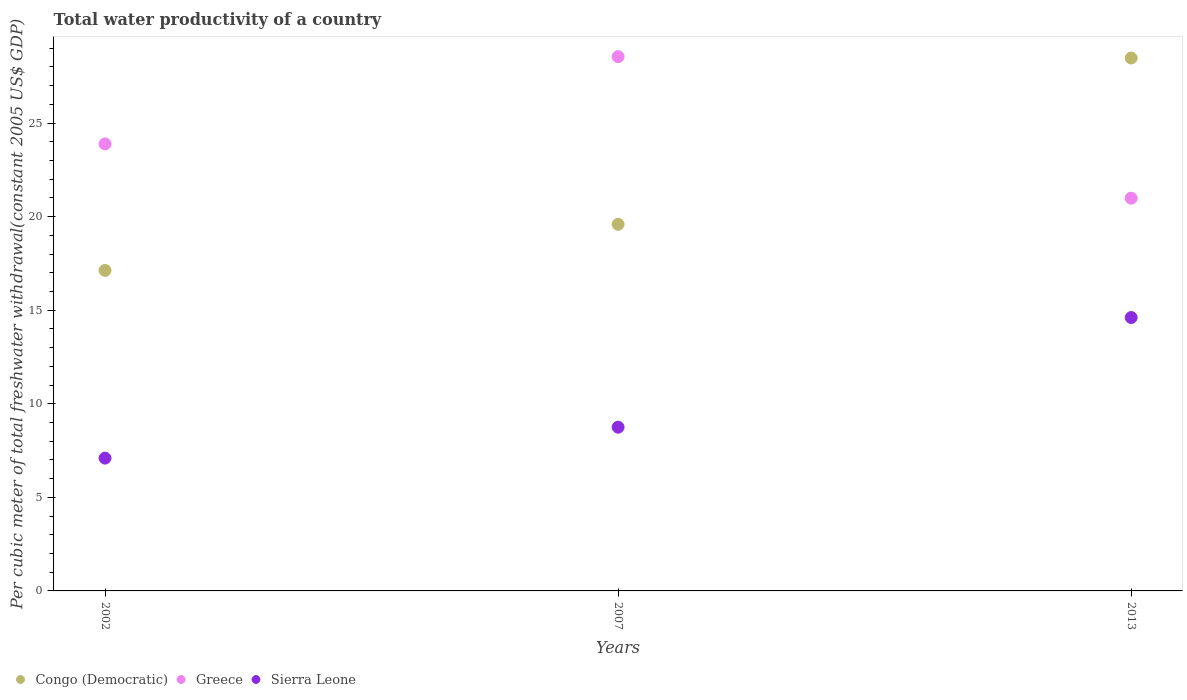Is the number of dotlines equal to the number of legend labels?
Offer a terse response. Yes. What is the total water productivity in Sierra Leone in 2013?
Give a very brief answer. 14.61. Across all years, what is the maximum total water productivity in Sierra Leone?
Offer a very short reply. 14.61. Across all years, what is the minimum total water productivity in Sierra Leone?
Offer a terse response. 7.1. In which year was the total water productivity in Sierra Leone maximum?
Provide a short and direct response. 2013. What is the total total water productivity in Congo (Democratic) in the graph?
Your answer should be compact. 65.19. What is the difference between the total water productivity in Congo (Democratic) in 2002 and that in 2007?
Your answer should be very brief. -2.46. What is the difference between the total water productivity in Sierra Leone in 2002 and the total water productivity in Greece in 2013?
Your response must be concise. -13.89. What is the average total water productivity in Greece per year?
Keep it short and to the point. 24.47. In the year 2007, what is the difference between the total water productivity in Greece and total water productivity in Sierra Leone?
Keep it short and to the point. 19.8. What is the ratio of the total water productivity in Greece in 2002 to that in 2007?
Your response must be concise. 0.84. What is the difference between the highest and the second highest total water productivity in Sierra Leone?
Give a very brief answer. 5.86. What is the difference between the highest and the lowest total water productivity in Greece?
Ensure brevity in your answer.  7.56. Is the sum of the total water productivity in Sierra Leone in 2002 and 2013 greater than the maximum total water productivity in Greece across all years?
Your answer should be compact. No. Is the total water productivity in Congo (Democratic) strictly greater than the total water productivity in Greece over the years?
Make the answer very short. No. Is the total water productivity in Sierra Leone strictly less than the total water productivity in Congo (Democratic) over the years?
Offer a very short reply. Yes. What is the difference between two consecutive major ticks on the Y-axis?
Your answer should be very brief. 5. Are the values on the major ticks of Y-axis written in scientific E-notation?
Make the answer very short. No. How many legend labels are there?
Provide a succinct answer. 3. How are the legend labels stacked?
Your response must be concise. Horizontal. What is the title of the graph?
Give a very brief answer. Total water productivity of a country. What is the label or title of the X-axis?
Your answer should be compact. Years. What is the label or title of the Y-axis?
Provide a succinct answer. Per cubic meter of total freshwater withdrawal(constant 2005 US$ GDP). What is the Per cubic meter of total freshwater withdrawal(constant 2005 US$ GDP) in Congo (Democratic) in 2002?
Provide a succinct answer. 17.13. What is the Per cubic meter of total freshwater withdrawal(constant 2005 US$ GDP) of Greece in 2002?
Offer a very short reply. 23.88. What is the Per cubic meter of total freshwater withdrawal(constant 2005 US$ GDP) of Sierra Leone in 2002?
Your answer should be very brief. 7.1. What is the Per cubic meter of total freshwater withdrawal(constant 2005 US$ GDP) of Congo (Democratic) in 2007?
Provide a succinct answer. 19.59. What is the Per cubic meter of total freshwater withdrawal(constant 2005 US$ GDP) in Greece in 2007?
Provide a succinct answer. 28.55. What is the Per cubic meter of total freshwater withdrawal(constant 2005 US$ GDP) of Sierra Leone in 2007?
Provide a short and direct response. 8.75. What is the Per cubic meter of total freshwater withdrawal(constant 2005 US$ GDP) in Congo (Democratic) in 2013?
Your answer should be compact. 28.47. What is the Per cubic meter of total freshwater withdrawal(constant 2005 US$ GDP) of Greece in 2013?
Ensure brevity in your answer.  20.98. What is the Per cubic meter of total freshwater withdrawal(constant 2005 US$ GDP) in Sierra Leone in 2013?
Offer a terse response. 14.61. Across all years, what is the maximum Per cubic meter of total freshwater withdrawal(constant 2005 US$ GDP) of Congo (Democratic)?
Ensure brevity in your answer.  28.47. Across all years, what is the maximum Per cubic meter of total freshwater withdrawal(constant 2005 US$ GDP) in Greece?
Offer a terse response. 28.55. Across all years, what is the maximum Per cubic meter of total freshwater withdrawal(constant 2005 US$ GDP) of Sierra Leone?
Your answer should be very brief. 14.61. Across all years, what is the minimum Per cubic meter of total freshwater withdrawal(constant 2005 US$ GDP) in Congo (Democratic)?
Give a very brief answer. 17.13. Across all years, what is the minimum Per cubic meter of total freshwater withdrawal(constant 2005 US$ GDP) of Greece?
Give a very brief answer. 20.98. Across all years, what is the minimum Per cubic meter of total freshwater withdrawal(constant 2005 US$ GDP) in Sierra Leone?
Offer a very short reply. 7.1. What is the total Per cubic meter of total freshwater withdrawal(constant 2005 US$ GDP) of Congo (Democratic) in the graph?
Your answer should be very brief. 65.19. What is the total Per cubic meter of total freshwater withdrawal(constant 2005 US$ GDP) of Greece in the graph?
Your answer should be very brief. 73.41. What is the total Per cubic meter of total freshwater withdrawal(constant 2005 US$ GDP) in Sierra Leone in the graph?
Provide a succinct answer. 30.45. What is the difference between the Per cubic meter of total freshwater withdrawal(constant 2005 US$ GDP) of Congo (Democratic) in 2002 and that in 2007?
Make the answer very short. -2.46. What is the difference between the Per cubic meter of total freshwater withdrawal(constant 2005 US$ GDP) of Greece in 2002 and that in 2007?
Provide a short and direct response. -4.66. What is the difference between the Per cubic meter of total freshwater withdrawal(constant 2005 US$ GDP) of Sierra Leone in 2002 and that in 2007?
Provide a short and direct response. -1.65. What is the difference between the Per cubic meter of total freshwater withdrawal(constant 2005 US$ GDP) in Congo (Democratic) in 2002 and that in 2013?
Offer a very short reply. -11.35. What is the difference between the Per cubic meter of total freshwater withdrawal(constant 2005 US$ GDP) of Greece in 2002 and that in 2013?
Offer a terse response. 2.9. What is the difference between the Per cubic meter of total freshwater withdrawal(constant 2005 US$ GDP) in Sierra Leone in 2002 and that in 2013?
Your answer should be very brief. -7.51. What is the difference between the Per cubic meter of total freshwater withdrawal(constant 2005 US$ GDP) of Congo (Democratic) in 2007 and that in 2013?
Offer a very short reply. -8.89. What is the difference between the Per cubic meter of total freshwater withdrawal(constant 2005 US$ GDP) in Greece in 2007 and that in 2013?
Keep it short and to the point. 7.56. What is the difference between the Per cubic meter of total freshwater withdrawal(constant 2005 US$ GDP) of Sierra Leone in 2007 and that in 2013?
Give a very brief answer. -5.86. What is the difference between the Per cubic meter of total freshwater withdrawal(constant 2005 US$ GDP) in Congo (Democratic) in 2002 and the Per cubic meter of total freshwater withdrawal(constant 2005 US$ GDP) in Greece in 2007?
Ensure brevity in your answer.  -11.42. What is the difference between the Per cubic meter of total freshwater withdrawal(constant 2005 US$ GDP) in Congo (Democratic) in 2002 and the Per cubic meter of total freshwater withdrawal(constant 2005 US$ GDP) in Sierra Leone in 2007?
Give a very brief answer. 8.38. What is the difference between the Per cubic meter of total freshwater withdrawal(constant 2005 US$ GDP) in Greece in 2002 and the Per cubic meter of total freshwater withdrawal(constant 2005 US$ GDP) in Sierra Leone in 2007?
Keep it short and to the point. 15.14. What is the difference between the Per cubic meter of total freshwater withdrawal(constant 2005 US$ GDP) in Congo (Democratic) in 2002 and the Per cubic meter of total freshwater withdrawal(constant 2005 US$ GDP) in Greece in 2013?
Provide a short and direct response. -3.86. What is the difference between the Per cubic meter of total freshwater withdrawal(constant 2005 US$ GDP) in Congo (Democratic) in 2002 and the Per cubic meter of total freshwater withdrawal(constant 2005 US$ GDP) in Sierra Leone in 2013?
Offer a terse response. 2.52. What is the difference between the Per cubic meter of total freshwater withdrawal(constant 2005 US$ GDP) of Greece in 2002 and the Per cubic meter of total freshwater withdrawal(constant 2005 US$ GDP) of Sierra Leone in 2013?
Make the answer very short. 9.28. What is the difference between the Per cubic meter of total freshwater withdrawal(constant 2005 US$ GDP) of Congo (Democratic) in 2007 and the Per cubic meter of total freshwater withdrawal(constant 2005 US$ GDP) of Greece in 2013?
Your answer should be compact. -1.4. What is the difference between the Per cubic meter of total freshwater withdrawal(constant 2005 US$ GDP) of Congo (Democratic) in 2007 and the Per cubic meter of total freshwater withdrawal(constant 2005 US$ GDP) of Sierra Leone in 2013?
Keep it short and to the point. 4.98. What is the difference between the Per cubic meter of total freshwater withdrawal(constant 2005 US$ GDP) in Greece in 2007 and the Per cubic meter of total freshwater withdrawal(constant 2005 US$ GDP) in Sierra Leone in 2013?
Keep it short and to the point. 13.94. What is the average Per cubic meter of total freshwater withdrawal(constant 2005 US$ GDP) of Congo (Democratic) per year?
Offer a very short reply. 21.73. What is the average Per cubic meter of total freshwater withdrawal(constant 2005 US$ GDP) in Greece per year?
Your response must be concise. 24.47. What is the average Per cubic meter of total freshwater withdrawal(constant 2005 US$ GDP) of Sierra Leone per year?
Ensure brevity in your answer.  10.15. In the year 2002, what is the difference between the Per cubic meter of total freshwater withdrawal(constant 2005 US$ GDP) of Congo (Democratic) and Per cubic meter of total freshwater withdrawal(constant 2005 US$ GDP) of Greece?
Ensure brevity in your answer.  -6.76. In the year 2002, what is the difference between the Per cubic meter of total freshwater withdrawal(constant 2005 US$ GDP) in Congo (Democratic) and Per cubic meter of total freshwater withdrawal(constant 2005 US$ GDP) in Sierra Leone?
Provide a short and direct response. 10.03. In the year 2002, what is the difference between the Per cubic meter of total freshwater withdrawal(constant 2005 US$ GDP) of Greece and Per cubic meter of total freshwater withdrawal(constant 2005 US$ GDP) of Sierra Leone?
Make the answer very short. 16.79. In the year 2007, what is the difference between the Per cubic meter of total freshwater withdrawal(constant 2005 US$ GDP) in Congo (Democratic) and Per cubic meter of total freshwater withdrawal(constant 2005 US$ GDP) in Greece?
Your response must be concise. -8.96. In the year 2007, what is the difference between the Per cubic meter of total freshwater withdrawal(constant 2005 US$ GDP) in Congo (Democratic) and Per cubic meter of total freshwater withdrawal(constant 2005 US$ GDP) in Sierra Leone?
Your answer should be compact. 10.84. In the year 2007, what is the difference between the Per cubic meter of total freshwater withdrawal(constant 2005 US$ GDP) of Greece and Per cubic meter of total freshwater withdrawal(constant 2005 US$ GDP) of Sierra Leone?
Your answer should be very brief. 19.8. In the year 2013, what is the difference between the Per cubic meter of total freshwater withdrawal(constant 2005 US$ GDP) of Congo (Democratic) and Per cubic meter of total freshwater withdrawal(constant 2005 US$ GDP) of Greece?
Your answer should be very brief. 7.49. In the year 2013, what is the difference between the Per cubic meter of total freshwater withdrawal(constant 2005 US$ GDP) of Congo (Democratic) and Per cubic meter of total freshwater withdrawal(constant 2005 US$ GDP) of Sierra Leone?
Offer a very short reply. 13.87. In the year 2013, what is the difference between the Per cubic meter of total freshwater withdrawal(constant 2005 US$ GDP) in Greece and Per cubic meter of total freshwater withdrawal(constant 2005 US$ GDP) in Sierra Leone?
Make the answer very short. 6.38. What is the ratio of the Per cubic meter of total freshwater withdrawal(constant 2005 US$ GDP) in Congo (Democratic) in 2002 to that in 2007?
Your answer should be very brief. 0.87. What is the ratio of the Per cubic meter of total freshwater withdrawal(constant 2005 US$ GDP) in Greece in 2002 to that in 2007?
Keep it short and to the point. 0.84. What is the ratio of the Per cubic meter of total freshwater withdrawal(constant 2005 US$ GDP) of Sierra Leone in 2002 to that in 2007?
Your answer should be compact. 0.81. What is the ratio of the Per cubic meter of total freshwater withdrawal(constant 2005 US$ GDP) of Congo (Democratic) in 2002 to that in 2013?
Your response must be concise. 0.6. What is the ratio of the Per cubic meter of total freshwater withdrawal(constant 2005 US$ GDP) of Greece in 2002 to that in 2013?
Provide a short and direct response. 1.14. What is the ratio of the Per cubic meter of total freshwater withdrawal(constant 2005 US$ GDP) in Sierra Leone in 2002 to that in 2013?
Give a very brief answer. 0.49. What is the ratio of the Per cubic meter of total freshwater withdrawal(constant 2005 US$ GDP) of Congo (Democratic) in 2007 to that in 2013?
Offer a very short reply. 0.69. What is the ratio of the Per cubic meter of total freshwater withdrawal(constant 2005 US$ GDP) in Greece in 2007 to that in 2013?
Make the answer very short. 1.36. What is the ratio of the Per cubic meter of total freshwater withdrawal(constant 2005 US$ GDP) of Sierra Leone in 2007 to that in 2013?
Offer a very short reply. 0.6. What is the difference between the highest and the second highest Per cubic meter of total freshwater withdrawal(constant 2005 US$ GDP) of Congo (Democratic)?
Provide a short and direct response. 8.89. What is the difference between the highest and the second highest Per cubic meter of total freshwater withdrawal(constant 2005 US$ GDP) in Greece?
Offer a terse response. 4.66. What is the difference between the highest and the second highest Per cubic meter of total freshwater withdrawal(constant 2005 US$ GDP) in Sierra Leone?
Make the answer very short. 5.86. What is the difference between the highest and the lowest Per cubic meter of total freshwater withdrawal(constant 2005 US$ GDP) in Congo (Democratic)?
Make the answer very short. 11.35. What is the difference between the highest and the lowest Per cubic meter of total freshwater withdrawal(constant 2005 US$ GDP) of Greece?
Your answer should be very brief. 7.56. What is the difference between the highest and the lowest Per cubic meter of total freshwater withdrawal(constant 2005 US$ GDP) of Sierra Leone?
Your answer should be very brief. 7.51. 